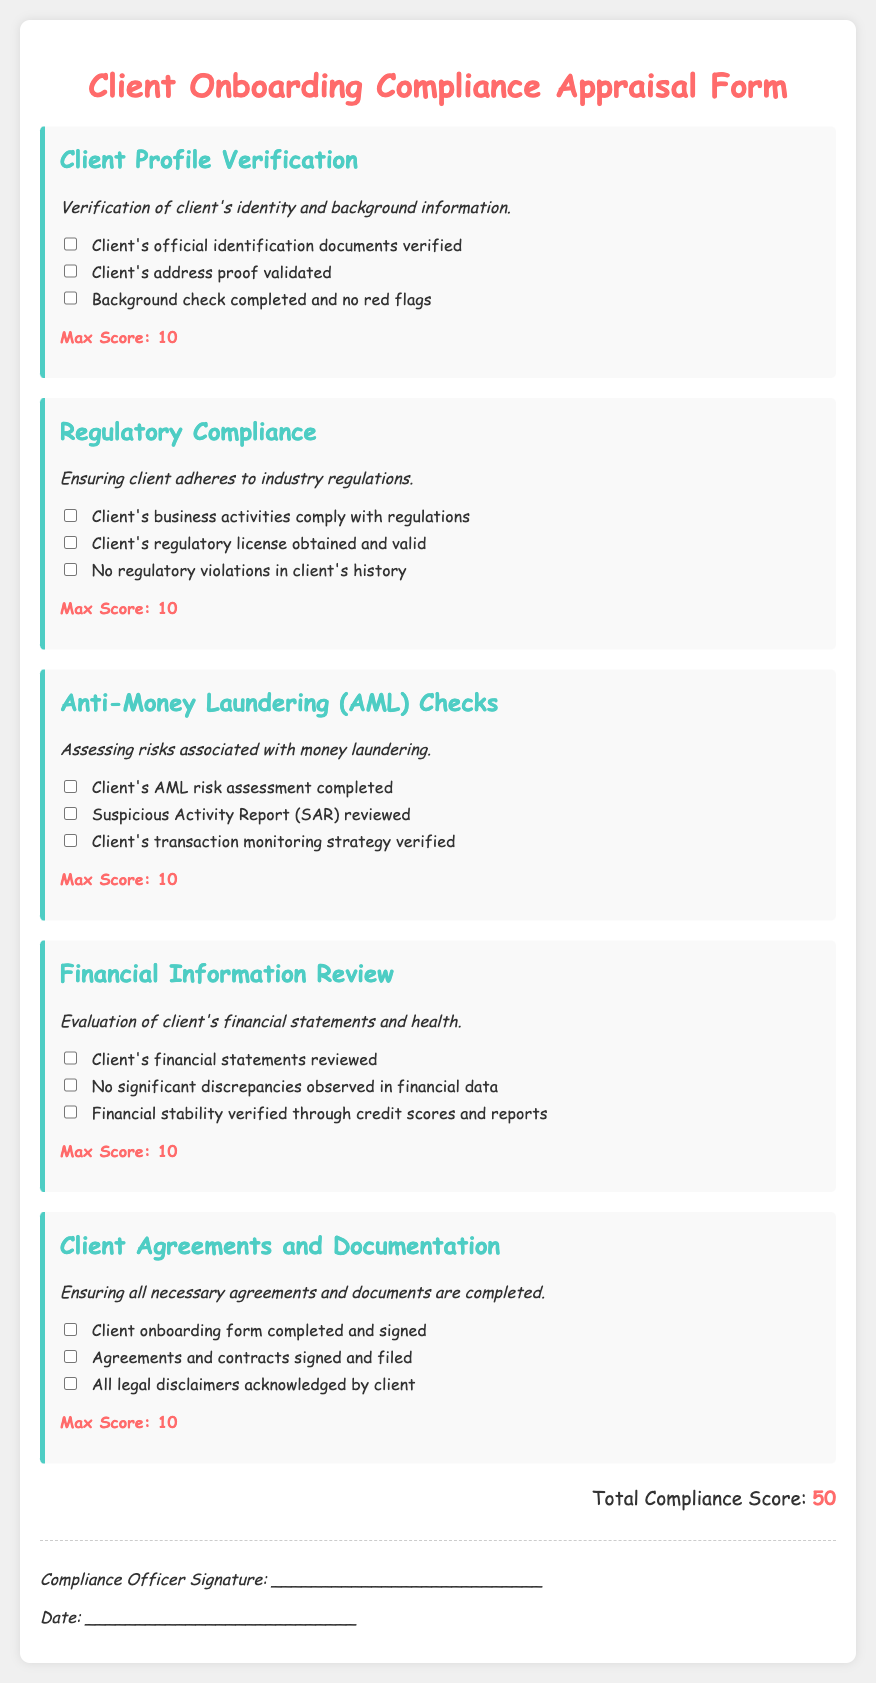What is the title of the document? The title of the document is prominently displayed at the top of the rendered form.
Answer: Client Onboarding Compliance Appraisal Form What is the max score for each section? Each section specifies the maximum score available within that particular area.
Answer: 10 How many sections are included in the document? The document lists the sections in a format, indicating multiple areas of assessment.
Answer: 5 What is the total compliance score? The total compliance score is calculated based on the assessments provided in the document.
Answer: 50 Which section addresses money laundering risks? The section title clearly highlights the focus on assessing money laundering risks.
Answer: Anti-Money Laundering (AML) Checks What is one item that needs to be verified in the Client Profile Verification section? The document outlines specific activities that need to be verified within this section.
Answer: Client's official identification documents verified Who is required to sign the form? The document designates who is responsible for the signature at the end of the appraisal form.
Answer: Compliance Officer What type of information is reviewed in the Financial Information Review section? The section highlights the financial aspects that are evaluated while onboarding a client.
Answer: Client's financial statements What is required from the client in the Client Agreements and Documentation section? This section details the agreements and documentation necessary for client onboarding.
Answer: Client onboarding form completed and signed 